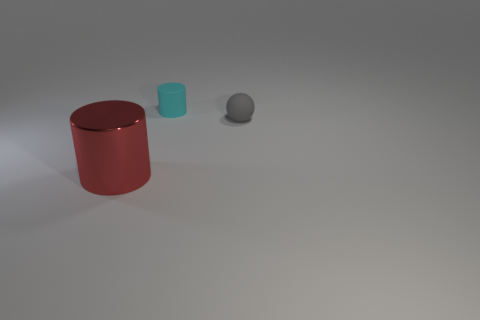Add 3 small cyan cylinders. How many objects exist? 6 Subtract all balls. How many objects are left? 2 Add 1 red things. How many red things exist? 2 Subtract 0 cyan spheres. How many objects are left? 3 Subtract all brown cylinders. Subtract all large metallic objects. How many objects are left? 2 Add 2 cyan objects. How many cyan objects are left? 3 